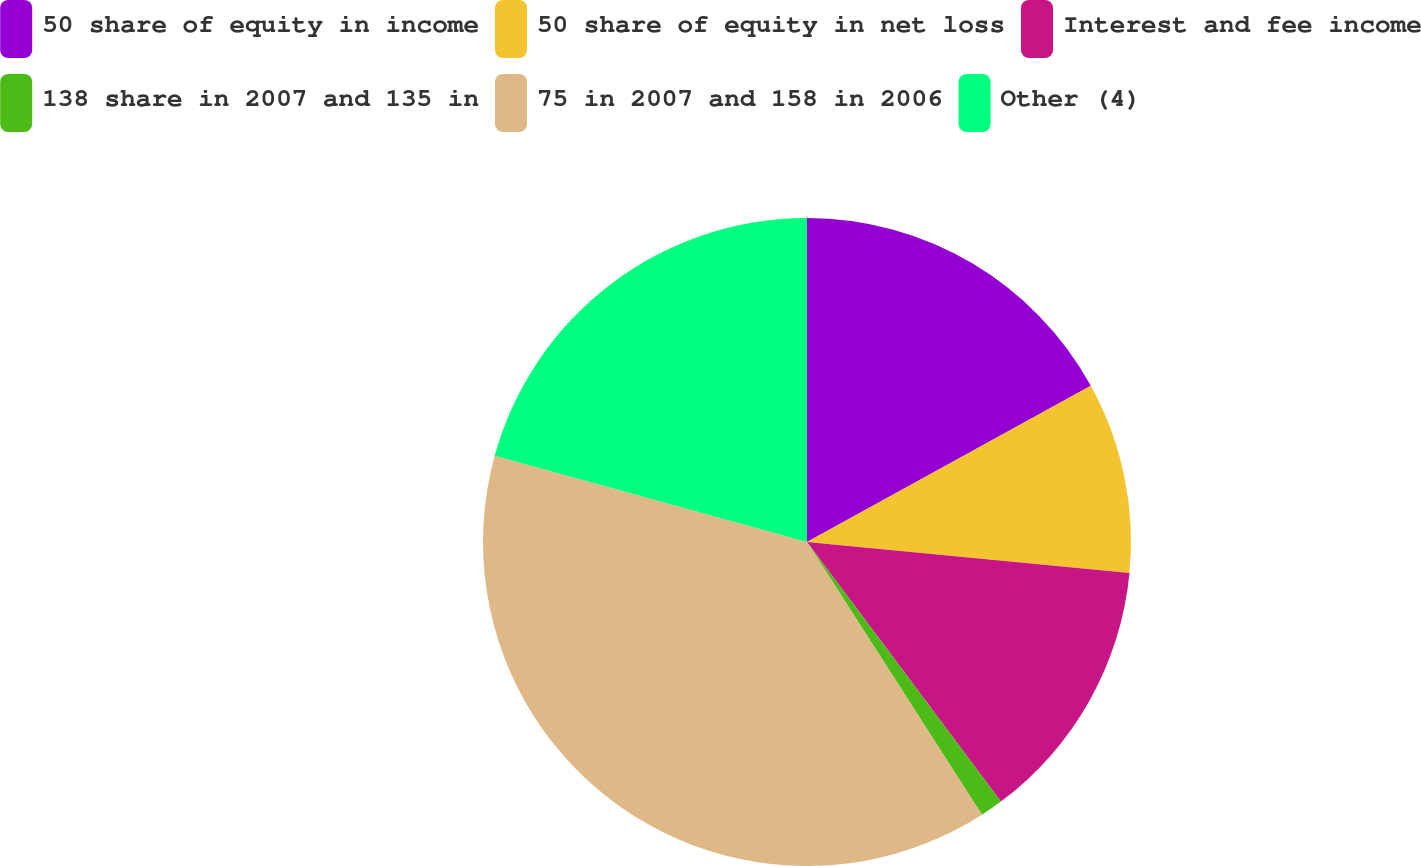Convert chart. <chart><loc_0><loc_0><loc_500><loc_500><pie_chart><fcel>50 share of equity in income<fcel>50 share of equity in net loss<fcel>Interest and fee income<fcel>138 share in 2007 and 135 in<fcel>75 in 2007 and 158 in 2006<fcel>Other (4)<nl><fcel>16.99%<fcel>9.54%<fcel>13.26%<fcel>1.13%<fcel>38.37%<fcel>20.71%<nl></chart> 